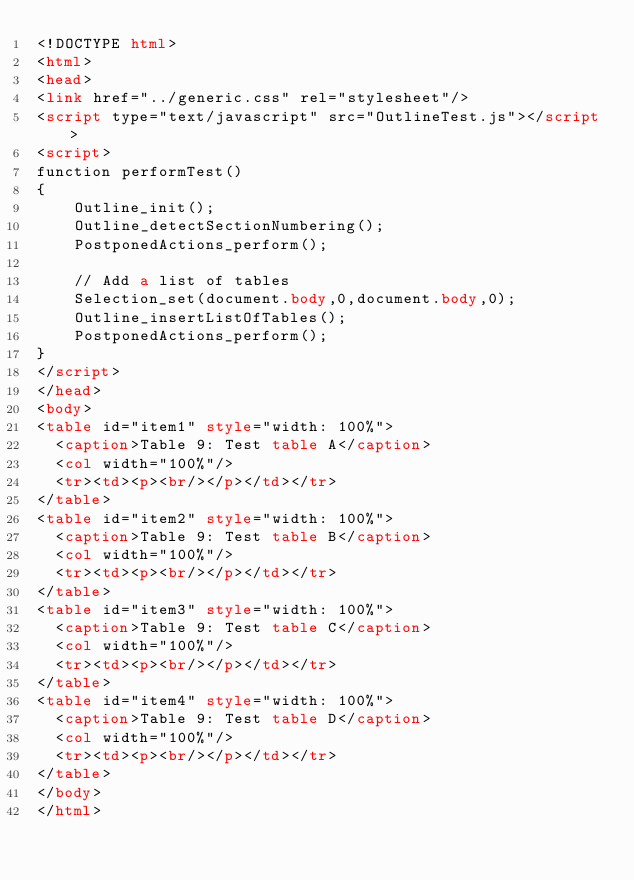<code> <loc_0><loc_0><loc_500><loc_500><_HTML_><!DOCTYPE html>
<html>
<head>
<link href="../generic.css" rel="stylesheet"/>
<script type="text/javascript" src="OutlineTest.js"></script>
<script>
function performTest()
{
    Outline_init();
    Outline_detectSectionNumbering();
    PostponedActions_perform();

    // Add a list of tables
    Selection_set(document.body,0,document.body,0);
    Outline_insertListOfTables();
    PostponedActions_perform();
}
</script>
</head>
<body>
<table id="item1" style="width: 100%">
  <caption>Table 9: Test table A</caption>
  <col width="100%"/>
  <tr><td><p><br/></p></td></tr>
</table>
<table id="item2" style="width: 100%">
  <caption>Table 9: Test table B</caption>
  <col width="100%"/>
  <tr><td><p><br/></p></td></tr>
</table>
<table id="item3" style="width: 100%">
  <caption>Table 9: Test table C</caption>
  <col width="100%"/>
  <tr><td><p><br/></p></td></tr>
</table>
<table id="item4" style="width: 100%">
  <caption>Table 9: Test table D</caption>
  <col width="100%"/>
  <tr><td><p><br/></p></td></tr>
</table>
</body>
</html>
</code> 